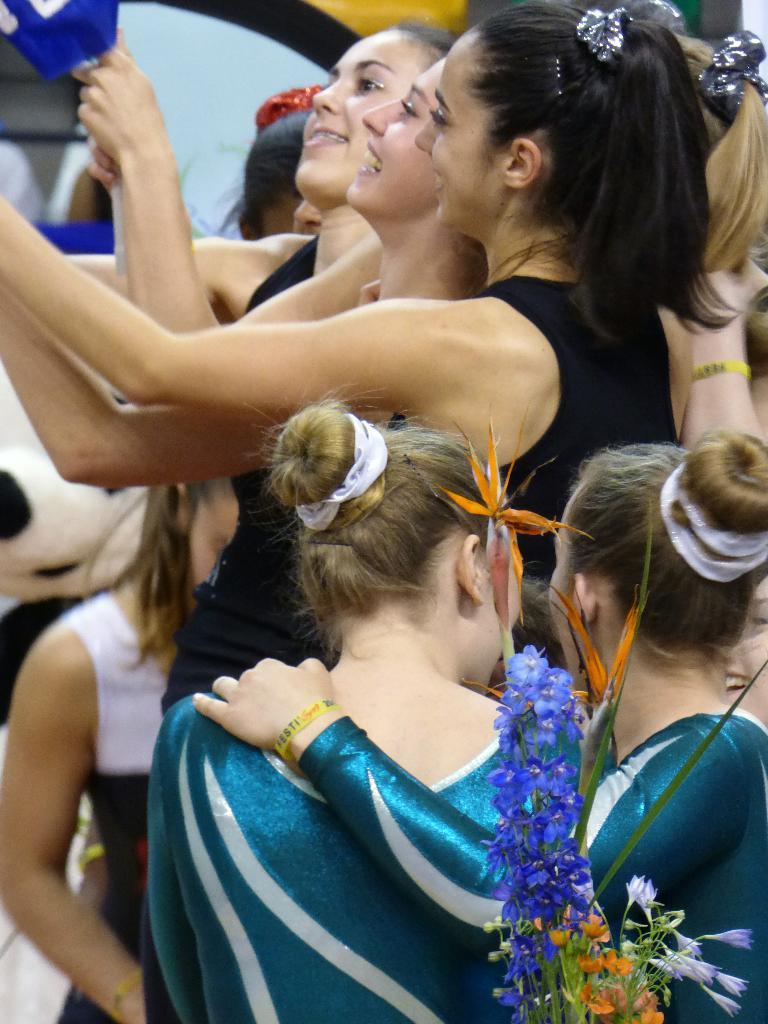What types of objects can be seen in the image? There are decorative items in the image. Can you describe the people in the background of the image? There is a group of people standing in the background of the image. How many kittens are sitting on the sponge in the image? There are no kittens or sponges present in the image. 